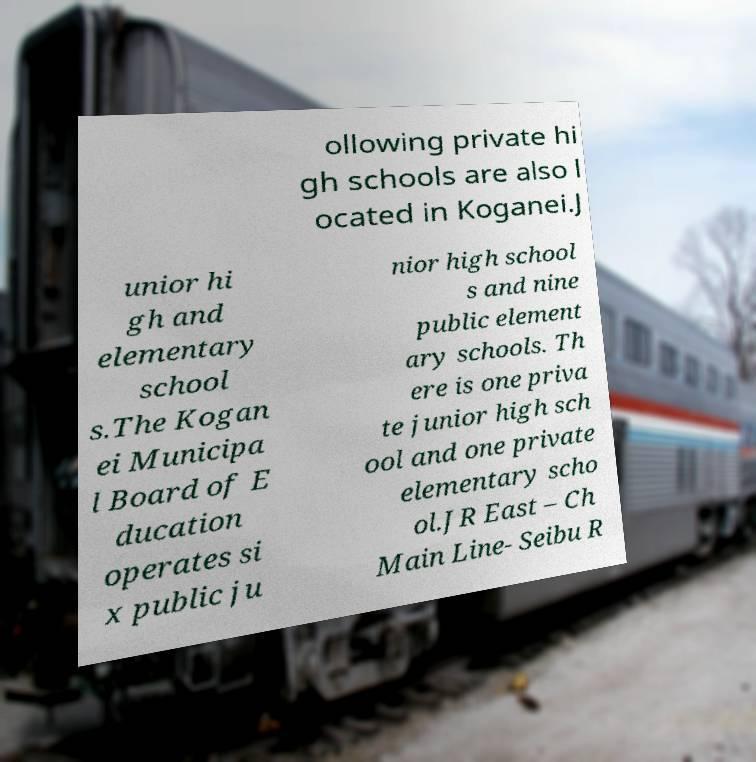Could you extract and type out the text from this image? ollowing private hi gh schools are also l ocated in Koganei.J unior hi gh and elementary school s.The Kogan ei Municipa l Board of E ducation operates si x public ju nior high school s and nine public element ary schools. Th ere is one priva te junior high sch ool and one private elementary scho ol.JR East – Ch Main Line- Seibu R 